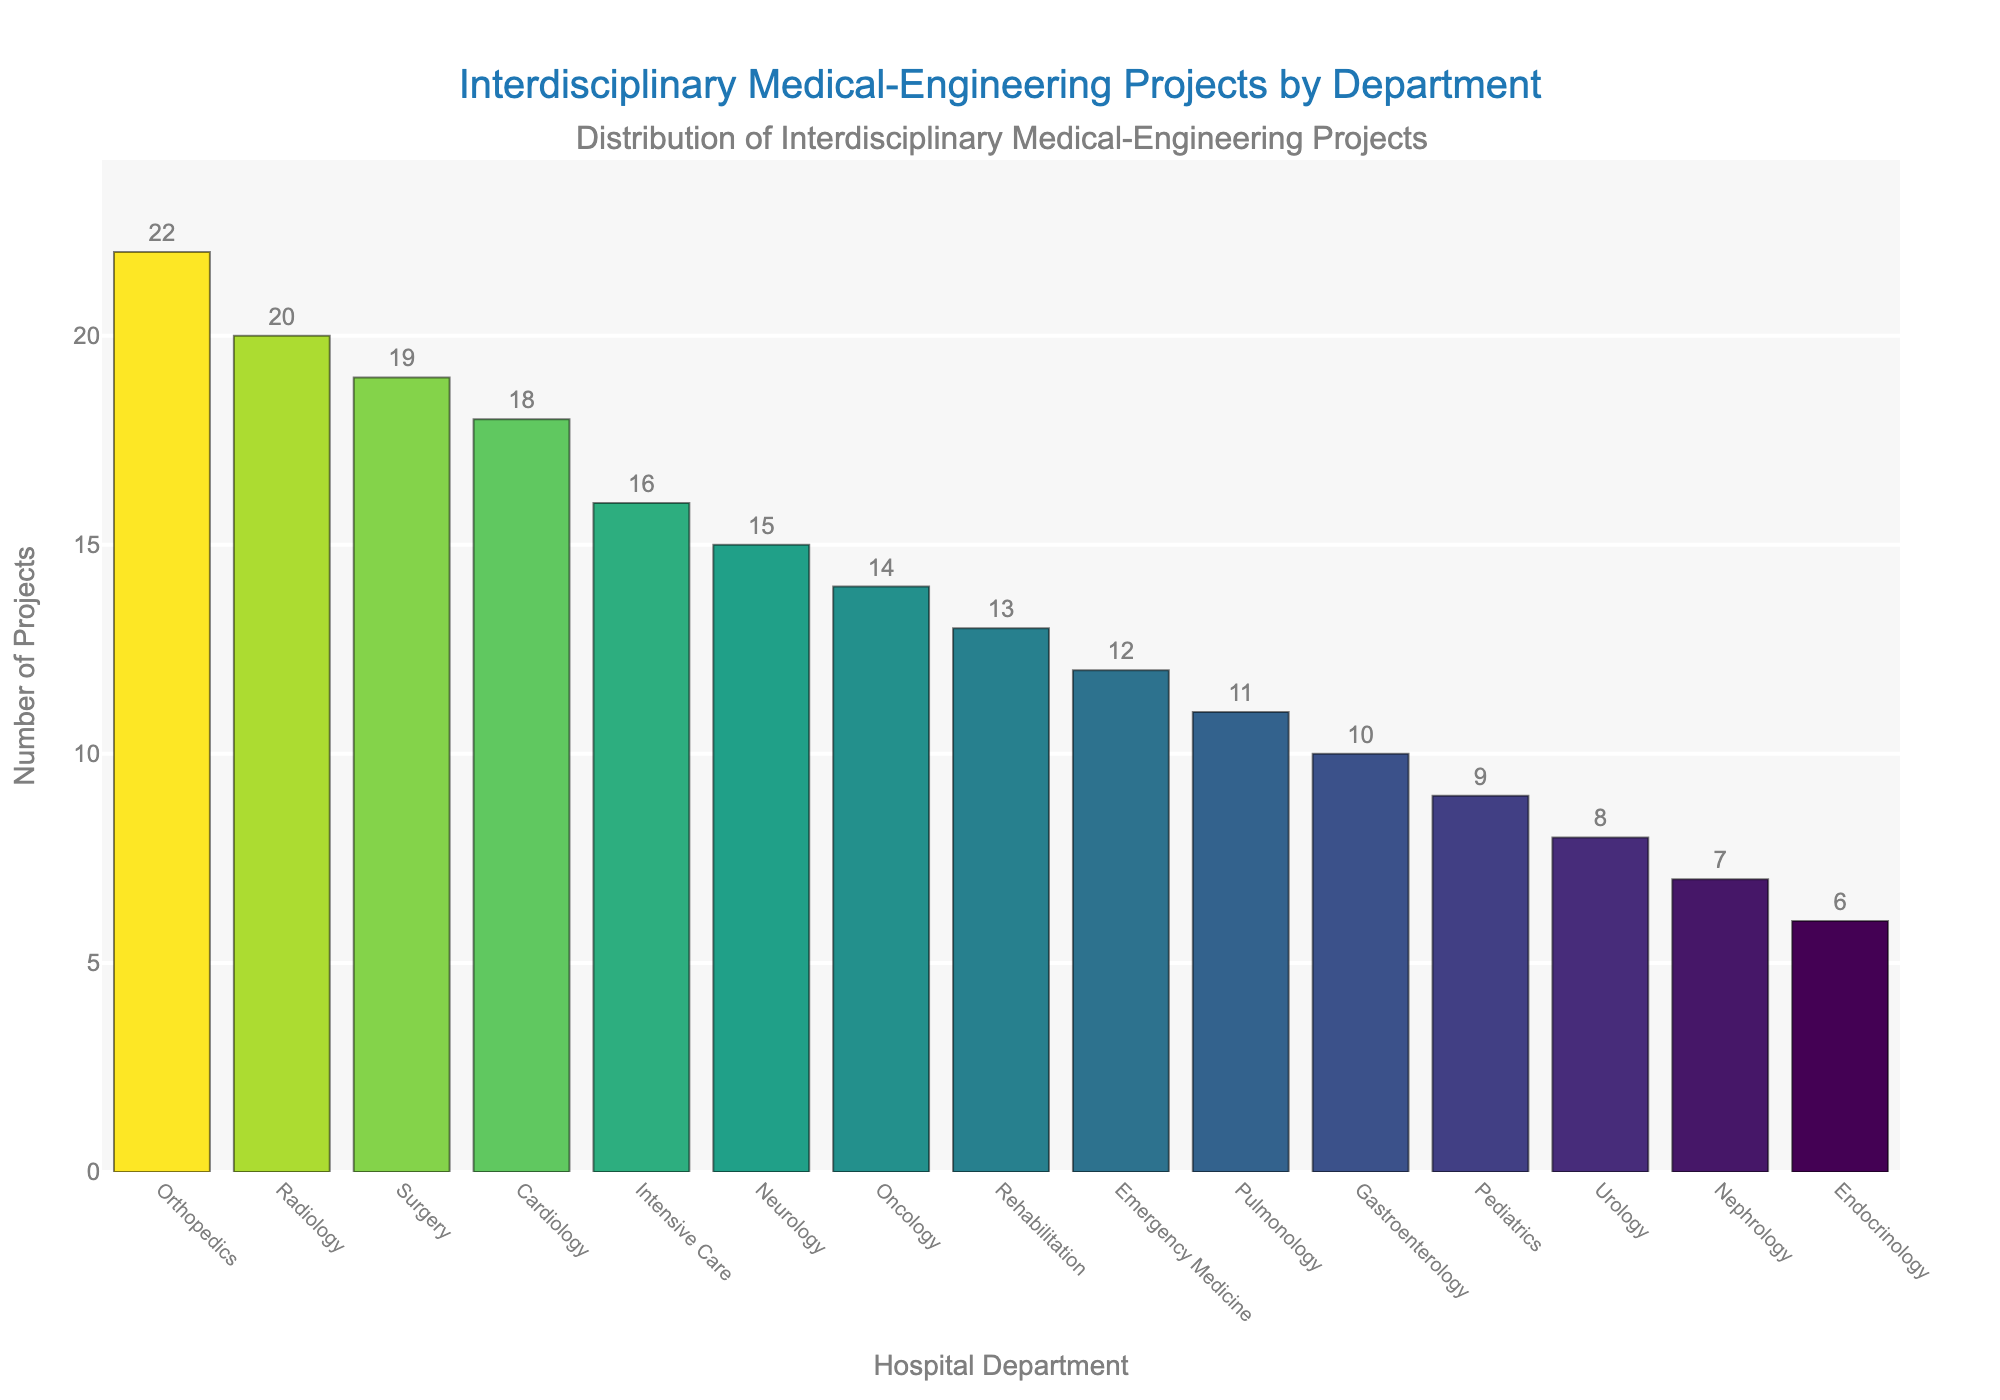Which department has the highest number of interdisciplinary medical-engineering projects? By examining the height of the bars, it's clear that Orthopedics has the tallest bar, indicating it has the highest number of projects.
Answer: Orthopedics What is the total number of interdisciplinary medical-engineering projects across all departments? Summing the values of all departments: 18 + 15 + 22 + 20 + 14 + 12 + 19 + 16 + 9 + 13 + 8 + 11 + 10 + 7 + 6 = 200
Answer: 200 Which department has fewer interdisciplinary projects, Neurology or Radiology? By comparing the heights of the bars for Neurology and Radiology, Neurology has a bar with 15 projects which is shorter than Radiology's 20 projects.
Answer: Neurology What is the difference between the number of projects in Cardiology and Oncology? Cardiology has 18 projects and Oncology has 14 projects. The difference is 18 - 14 = 4
Answer: 4 What is the average number of projects per department? There are 15 departments. Summing the project numbers gives 200, and dividing by 15 gives the average: 200 / 15 ≈ 13.33
Answer: 13.33 What is the ratio of projects in Surgery to Pulmonology? Surgery has 19 projects, and Pulmonology has 11 projects. The ratio is 19:11.
Answer: 19:11 Which department has more projects, Pediatrics or Gastroenterology? Comparing the bars for Pediatrics and Gastroenterology, Pediatrics has 9 projects, and Gastroenterology has 10 projects. Therefore, Gastroenterology has more.
Answer: Gastroenterology How many more projects does Intensive Care have compared to Urology? Intensive Care has 16 projects, and Urology has 8 projects. The difference is 16 - 8 = 8.
Answer: 8 What is the median number of interdisciplinary projects across all departments? Sorting the projects in ascending order: 6, 7, 8, 9, 10, 11, 12, 13, 14, 15, 16, 18, 19, 20, 22. With 15 data points, the median is the 8th value, which is 13.
Answer: 13 Which department has the fewest interdisciplinary projects and how many does it have? By looking for the shortest bar, Endocrinology has the fewest projects, with 6.
Answer: Endocrinology Which two departments combined have a total of 30 projects? Combining departments to find a total of 30: Cardiology (18) + Neurology (15) = 33 (too high), Radiology (20) + Urology (8) = 28 (close), Intensive Care (16) + Oncology (14) = 30
Answer: Intensive Care, Oncology 